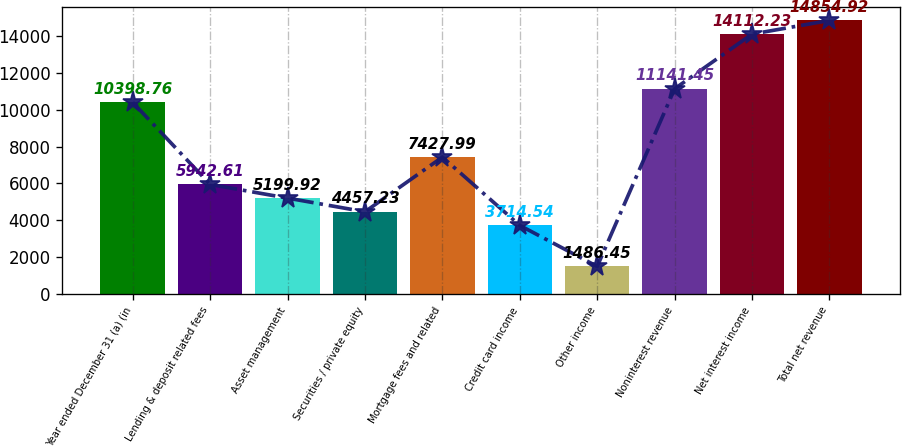Convert chart. <chart><loc_0><loc_0><loc_500><loc_500><bar_chart><fcel>Year ended December 31 (a) (in<fcel>Lending & deposit related fees<fcel>Asset management<fcel>Securities / private equity<fcel>Mortgage fees and related<fcel>Credit card income<fcel>Other income<fcel>Noninterest revenue<fcel>Net interest income<fcel>Total net revenue<nl><fcel>10398.8<fcel>5942.61<fcel>5199.92<fcel>4457.23<fcel>7427.99<fcel>3714.54<fcel>1486.45<fcel>11141.5<fcel>14112.2<fcel>14854.9<nl></chart> 